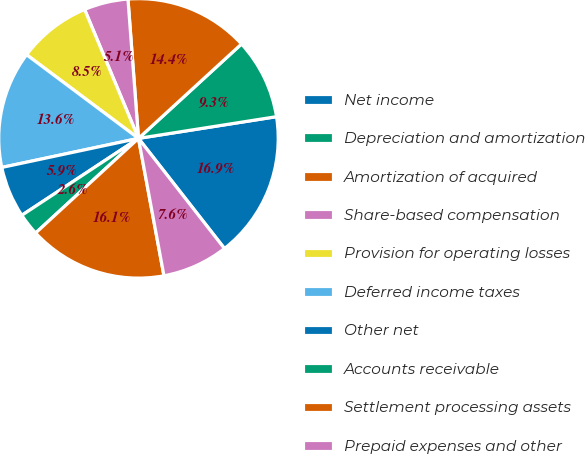<chart> <loc_0><loc_0><loc_500><loc_500><pie_chart><fcel>Net income<fcel>Depreciation and amortization<fcel>Amortization of acquired<fcel>Share-based compensation<fcel>Provision for operating losses<fcel>Deferred income taxes<fcel>Other net<fcel>Accounts receivable<fcel>Settlement processing assets<fcel>Prepaid expenses and other<nl><fcel>16.93%<fcel>9.32%<fcel>14.39%<fcel>5.1%<fcel>8.48%<fcel>13.55%<fcel>5.94%<fcel>2.56%<fcel>16.08%<fcel>7.63%<nl></chart> 